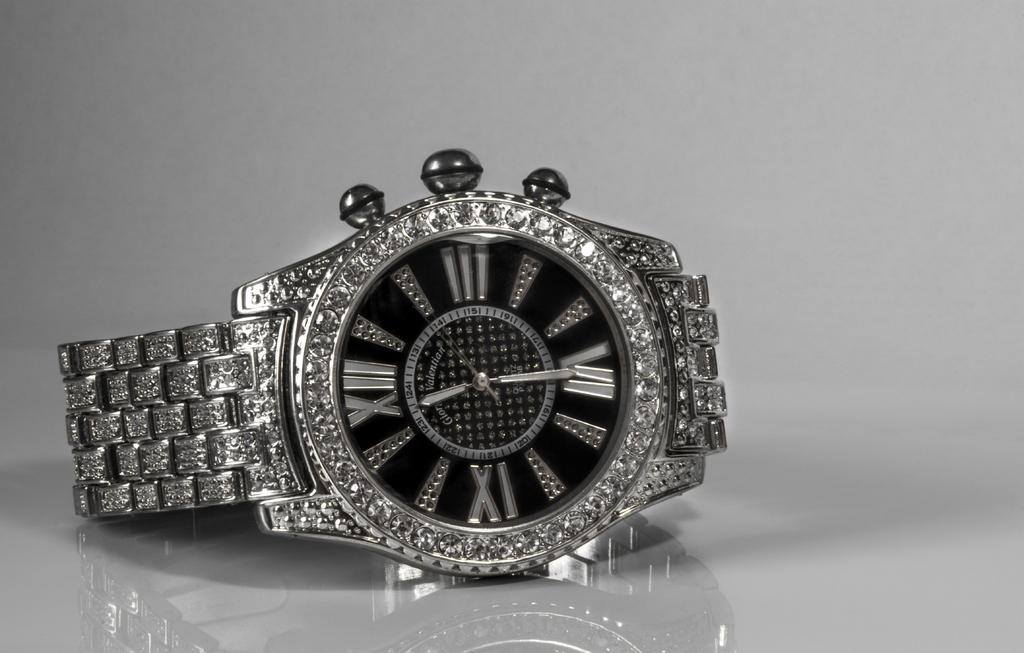<image>
Relay a brief, clear account of the picture shown. Silver and black wristwatch with the hands on the number 12 and 6. 